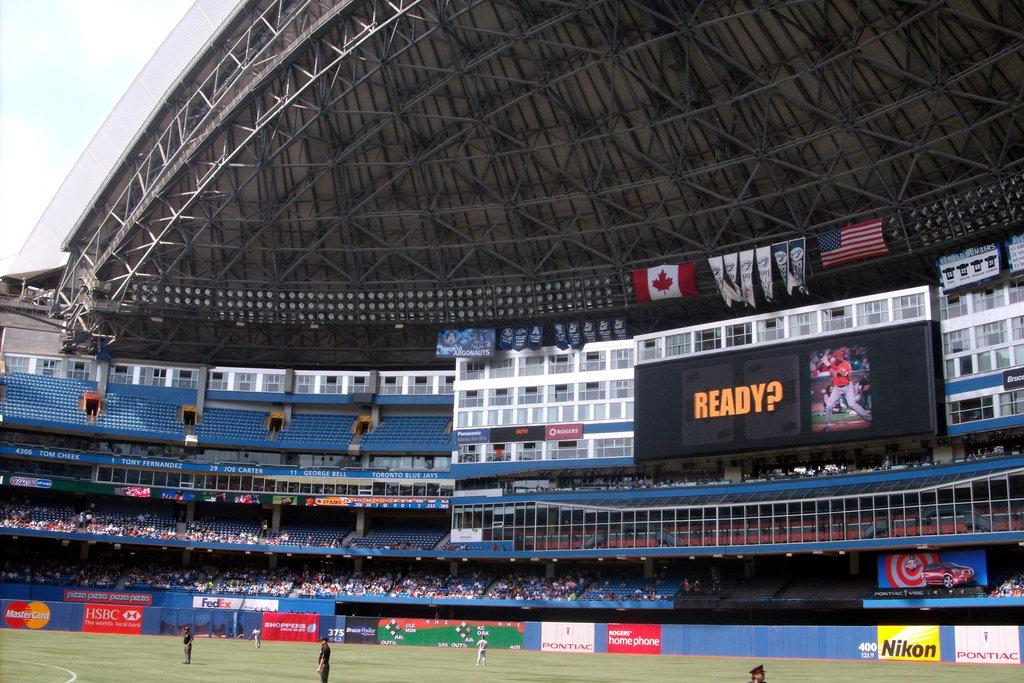What is the screen asking?
Keep it short and to the point. Ready?. What brand is the yellow board advertising?
Offer a very short reply. Nikon. 